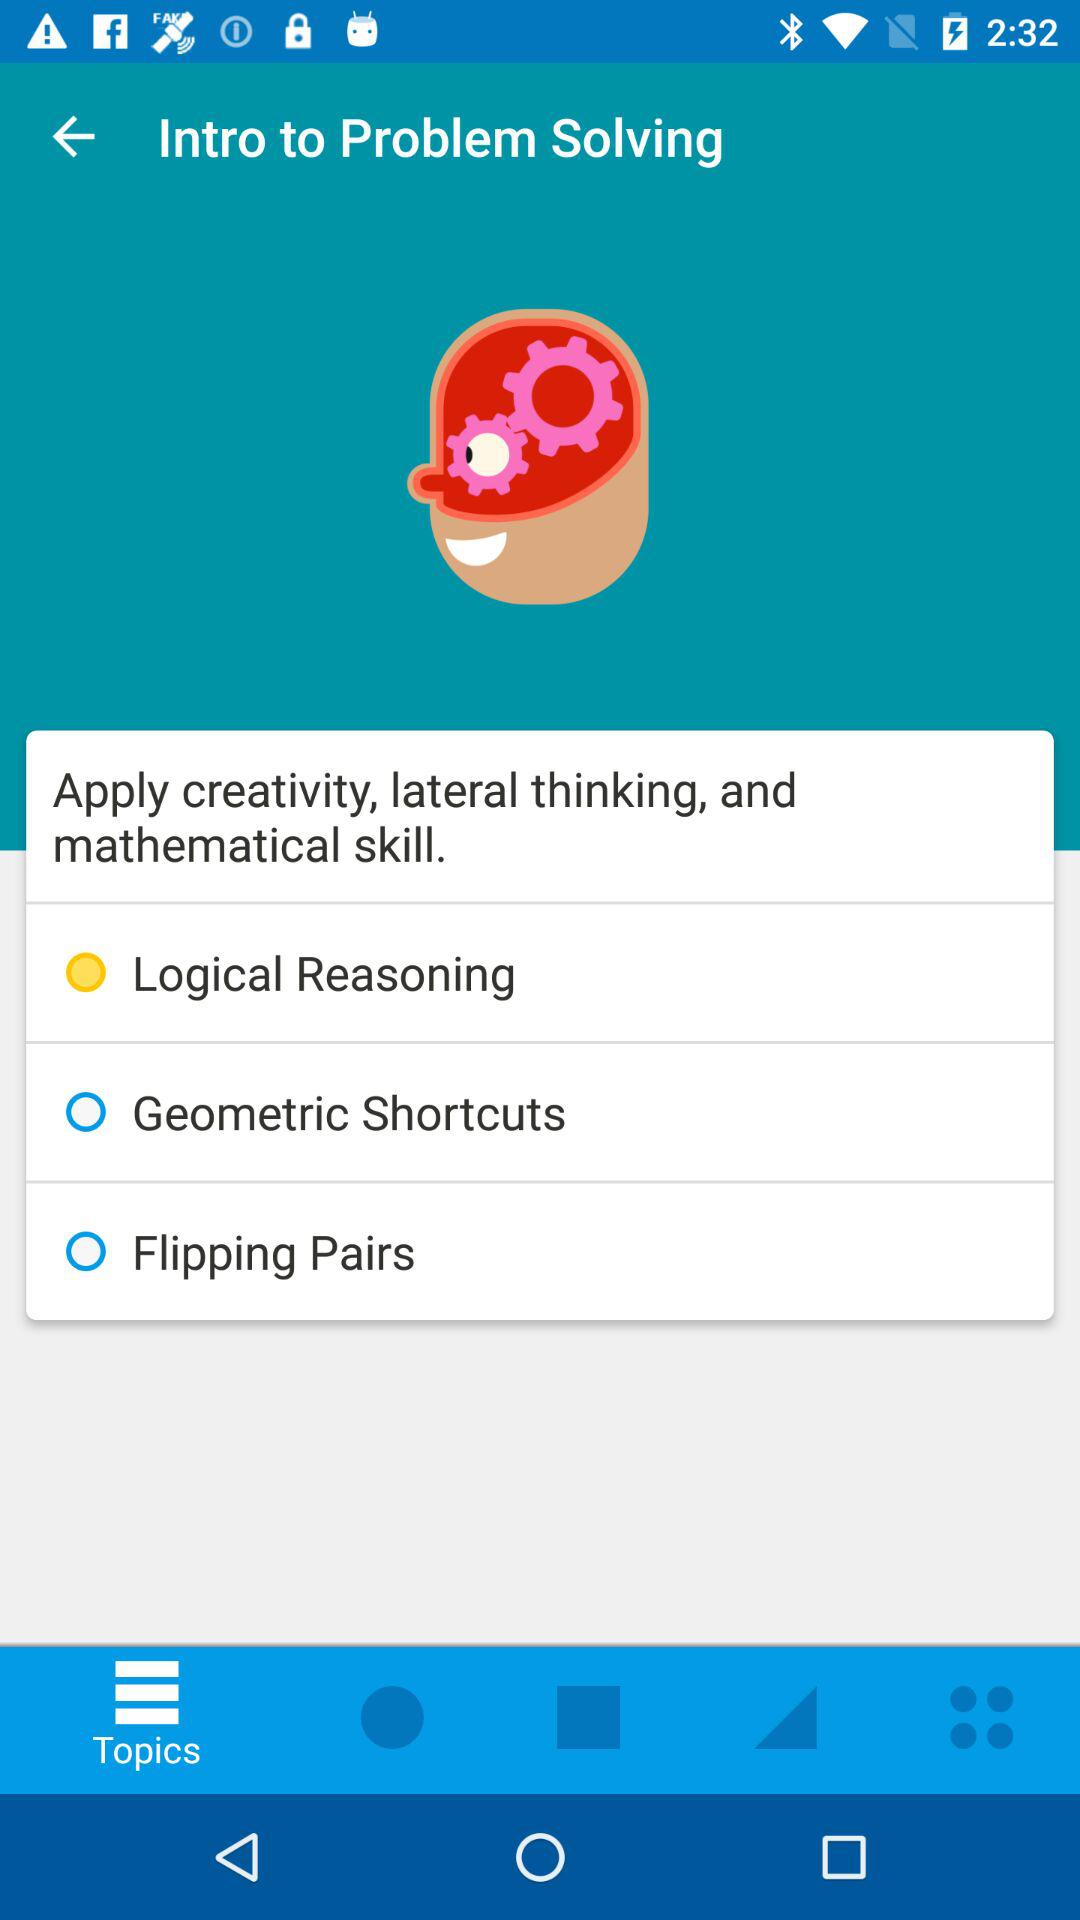What is the starting time shown on the screen?
When the provided information is insufficient, respond with <no answer>. <no answer> 